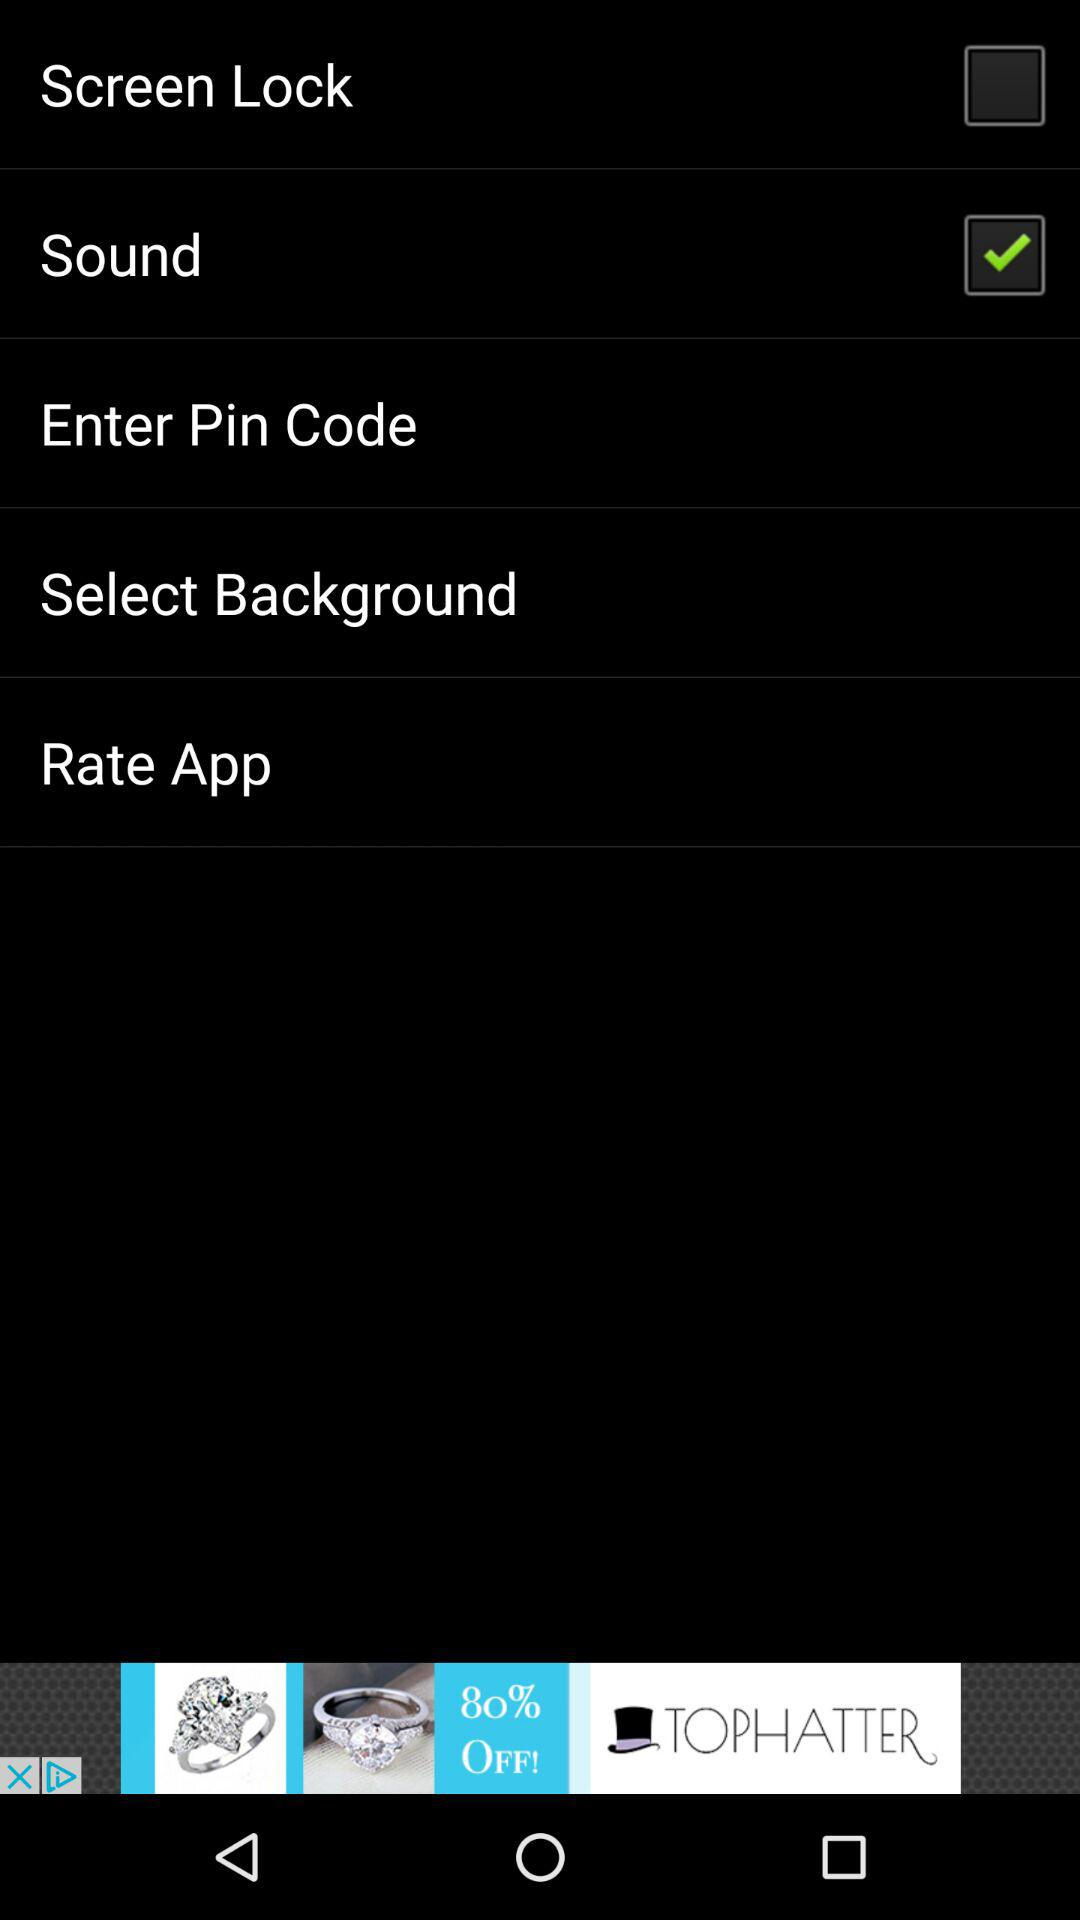What option has been selected? The selected option is "Sound". 